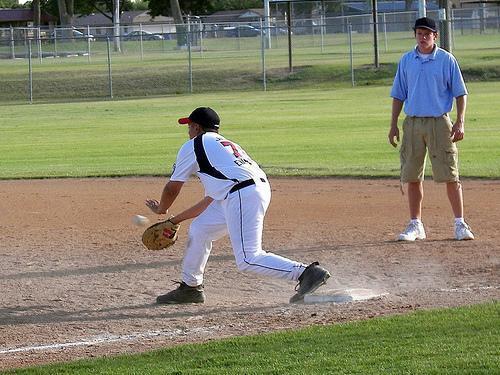How many people are there?
Give a very brief answer. 2. 